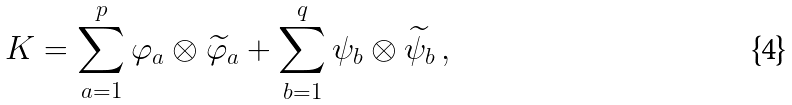<formula> <loc_0><loc_0><loc_500><loc_500>K = \sum _ { a = 1 } ^ { p } \varphi _ { a } \otimes \widetilde { \varphi } _ { a } + \sum _ { b = 1 } ^ { q } \psi _ { b } \otimes \widetilde { \psi } _ { b } \, ,</formula> 